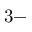<formula> <loc_0><loc_0><loc_500><loc_500>3 -</formula> 